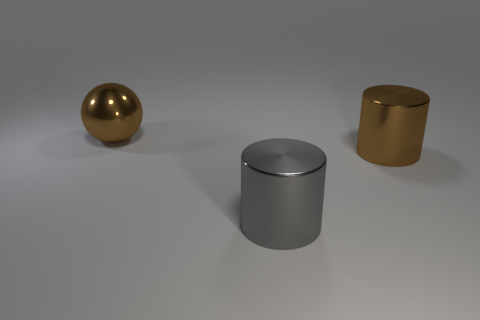How many objects are large brown objects on the left side of the gray metallic cylinder or large metallic things that are in front of the large ball?
Ensure brevity in your answer.  3. Is there a brown object that is on the left side of the large brown metallic thing that is in front of the brown metal sphere?
Keep it short and to the point. Yes. There is a big brown cylinder; how many large cylinders are in front of it?
Keep it short and to the point. 1. How many other things are the same color as the large shiny ball?
Give a very brief answer. 1. Are there fewer gray metal cylinders that are left of the large gray cylinder than large brown shiny balls on the right side of the brown cylinder?
Provide a succinct answer. No. What number of objects are cylinders on the right side of the gray thing or small red metallic objects?
Your answer should be very brief. 1. What number of objects are on the left side of the metal thing in front of the brown thing that is in front of the brown shiny sphere?
Your answer should be very brief. 1. What number of cylinders are big shiny things or large brown things?
Give a very brief answer. 2. What is the color of the metal object that is left of the gray shiny cylinder that is in front of the brown metallic thing that is behind the brown metallic cylinder?
Your response must be concise. Brown. What number of other objects are there of the same size as the brown metallic sphere?
Ensure brevity in your answer.  2. 